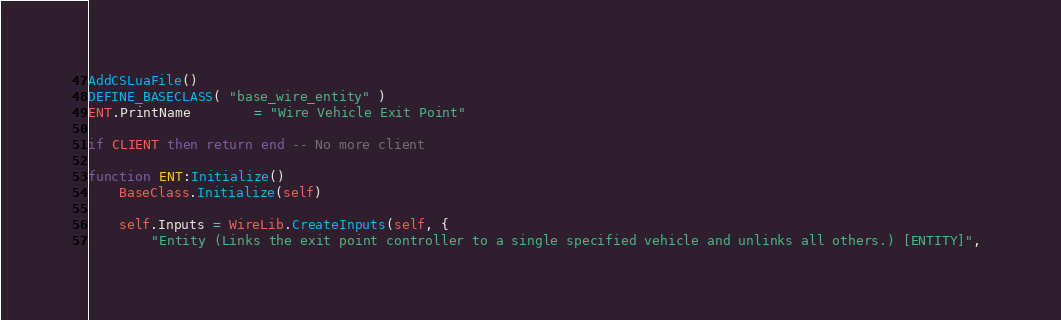Convert code to text. <code><loc_0><loc_0><loc_500><loc_500><_Lua_>AddCSLuaFile()
DEFINE_BASECLASS( "base_wire_entity" )
ENT.PrintName		= "Wire Vehicle Exit Point"

if CLIENT then return end -- No more client

function ENT:Initialize()
	BaseClass.Initialize(self)

	self.Inputs = WireLib.CreateInputs(self, {
		"Entity (Links the exit point controller to a single specified vehicle and unlinks all others.) [ENTITY]", </code> 